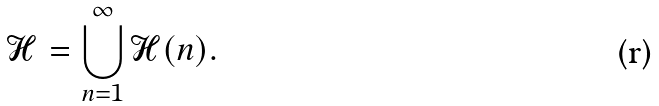<formula> <loc_0><loc_0><loc_500><loc_500>\mathcal { H } = \bigcup _ { n = 1 } ^ { \infty } \mathcal { H } ( n ) .</formula> 